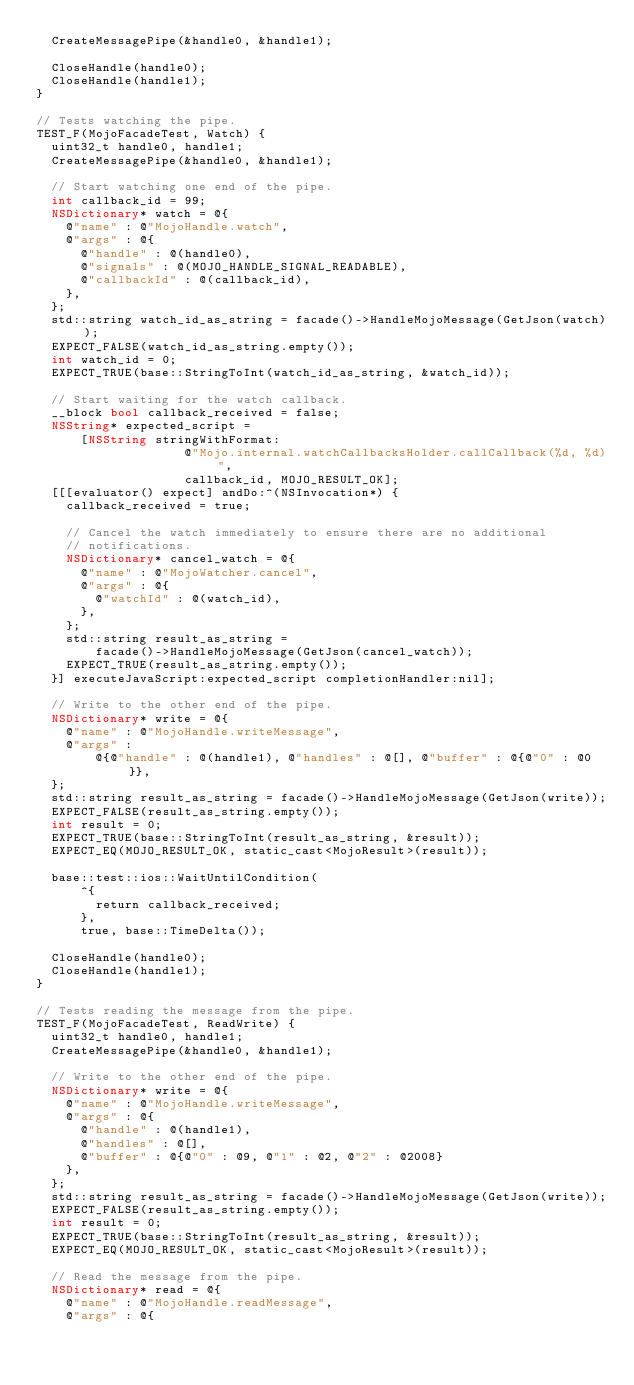<code> <loc_0><loc_0><loc_500><loc_500><_ObjectiveC_>  CreateMessagePipe(&handle0, &handle1);

  CloseHandle(handle0);
  CloseHandle(handle1);
}

// Tests watching the pipe.
TEST_F(MojoFacadeTest, Watch) {
  uint32_t handle0, handle1;
  CreateMessagePipe(&handle0, &handle1);

  // Start watching one end of the pipe.
  int callback_id = 99;
  NSDictionary* watch = @{
    @"name" : @"MojoHandle.watch",
    @"args" : @{
      @"handle" : @(handle0),
      @"signals" : @(MOJO_HANDLE_SIGNAL_READABLE),
      @"callbackId" : @(callback_id),
    },
  };
  std::string watch_id_as_string = facade()->HandleMojoMessage(GetJson(watch));
  EXPECT_FALSE(watch_id_as_string.empty());
  int watch_id = 0;
  EXPECT_TRUE(base::StringToInt(watch_id_as_string, &watch_id));

  // Start waiting for the watch callback.
  __block bool callback_received = false;
  NSString* expected_script =
      [NSString stringWithFormat:
                    @"Mojo.internal.watchCallbacksHolder.callCallback(%d, %d)",
                    callback_id, MOJO_RESULT_OK];
  [[[evaluator() expect] andDo:^(NSInvocation*) {
    callback_received = true;

    // Cancel the watch immediately to ensure there are no additional
    // notifications.
    NSDictionary* cancel_watch = @{
      @"name" : @"MojoWatcher.cancel",
      @"args" : @{
        @"watchId" : @(watch_id),
      },
    };
    std::string result_as_string =
        facade()->HandleMojoMessage(GetJson(cancel_watch));
    EXPECT_TRUE(result_as_string.empty());
  }] executeJavaScript:expected_script completionHandler:nil];

  // Write to the other end of the pipe.
  NSDictionary* write = @{
    @"name" : @"MojoHandle.writeMessage",
    @"args" :
        @{@"handle" : @(handle1), @"handles" : @[], @"buffer" : @{@"0" : @0}},
  };
  std::string result_as_string = facade()->HandleMojoMessage(GetJson(write));
  EXPECT_FALSE(result_as_string.empty());
  int result = 0;
  EXPECT_TRUE(base::StringToInt(result_as_string, &result));
  EXPECT_EQ(MOJO_RESULT_OK, static_cast<MojoResult>(result));

  base::test::ios::WaitUntilCondition(
      ^{
        return callback_received;
      },
      true, base::TimeDelta());

  CloseHandle(handle0);
  CloseHandle(handle1);
}

// Tests reading the message from the pipe.
TEST_F(MojoFacadeTest, ReadWrite) {
  uint32_t handle0, handle1;
  CreateMessagePipe(&handle0, &handle1);

  // Write to the other end of the pipe.
  NSDictionary* write = @{
    @"name" : @"MojoHandle.writeMessage",
    @"args" : @{
      @"handle" : @(handle1),
      @"handles" : @[],
      @"buffer" : @{@"0" : @9, @"1" : @2, @"2" : @2008}
    },
  };
  std::string result_as_string = facade()->HandleMojoMessage(GetJson(write));
  EXPECT_FALSE(result_as_string.empty());
  int result = 0;
  EXPECT_TRUE(base::StringToInt(result_as_string, &result));
  EXPECT_EQ(MOJO_RESULT_OK, static_cast<MojoResult>(result));

  // Read the message from the pipe.
  NSDictionary* read = @{
    @"name" : @"MojoHandle.readMessage",
    @"args" : @{</code> 